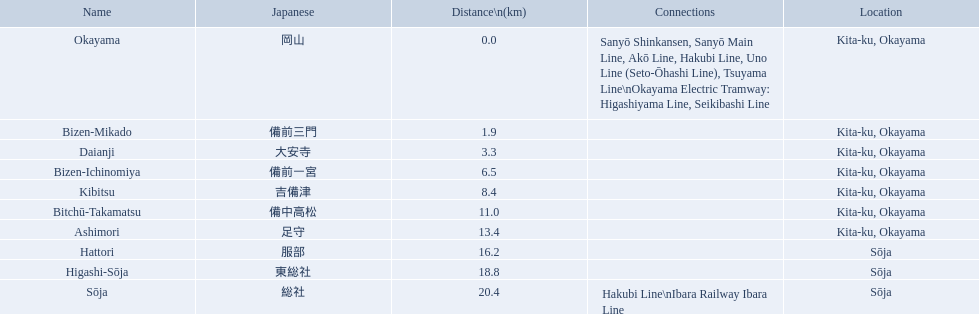What are all the stops on the kibi line? Okayama, Bizen-Mikado, Daianji, Bizen-Ichinomiya, Kibitsu, Bitchū-Takamatsu, Ashimori, Hattori, Higashi-Sōja, Sōja. What are the measurements of these stops from the commencement of the line? 0.0, 1.9, 3.3, 6.5, 8.4, 11.0, 13.4, 16.2, 18.8, 20.4. Of these, which is more than 1 km? 1.9, 3.3, 6.5, 8.4, 11.0, 13.4, 16.2, 18.8, 20.4. Of these, which is less than 2 km? 1.9. Which stop is located at this distance from the beginning of the line? Bizen-Mikado. Parse the full table. {'header': ['Name', 'Japanese', 'Distance\\n(km)', 'Connections', 'Location'], 'rows': [['Okayama', '岡山', '0.0', 'Sanyō Shinkansen, Sanyō Main Line, Akō Line, Hakubi Line, Uno Line (Seto-Ōhashi Line), Tsuyama Line\\nOkayama Electric Tramway: Higashiyama Line, Seikibashi Line', 'Kita-ku, Okayama'], ['Bizen-Mikado', '備前三門', '1.9', '', 'Kita-ku, Okayama'], ['Daianji', '大安寺', '3.3', '', 'Kita-ku, Okayama'], ['Bizen-Ichinomiya', '備前一宮', '6.5', '', 'Kita-ku, Okayama'], ['Kibitsu', '吉備津', '8.4', '', 'Kita-ku, Okayama'], ['Bitchū-Takamatsu', '備中高松', '11.0', '', 'Kita-ku, Okayama'], ['Ashimori', '足守', '13.4', '', 'Kita-ku, Okayama'], ['Hattori', '服部', '16.2', '', 'Sōja'], ['Higashi-Sōja', '東総社', '18.8', '', 'Sōja'], ['Sōja', '総社', '20.4', 'Hakubi Line\\nIbara Railway Ibara Line', 'Sōja']]} What are the entirety of the stations on the kibi line? Okayama, Bizen-Mikado, Daianji, Bizen-Ichinomiya, Kibitsu, Bitchū-Takamatsu, Ashimori, Hattori, Higashi-Sōja, Sōja. What are the spans of these stations from the initiation of the line? 0.0, 1.9, 3.3, 6.5, 8.4, 11.0, 13.4, 16.2, 18.8, 20.4. Of these, which is over 1 km? 1.9, 3.3, 6.5, 8.4, 11.0, 13.4, 16.2, 18.8, 20.4. Of these, which is below 2 km? 1.9. Which station is situated at this distance from the start of the line? Bizen-Mikado. 